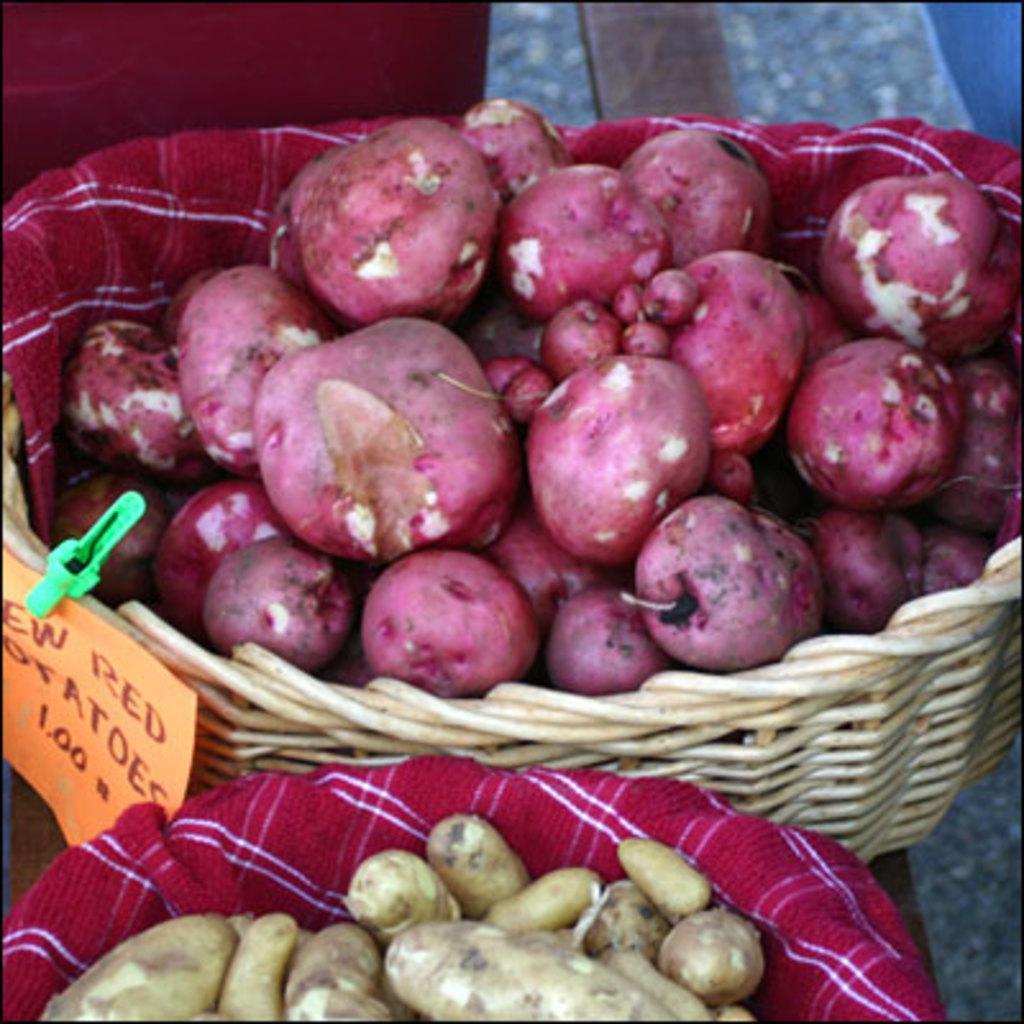Please provide a concise description of this image. This image consists of red potatoes in the basket are kept on the floor. 